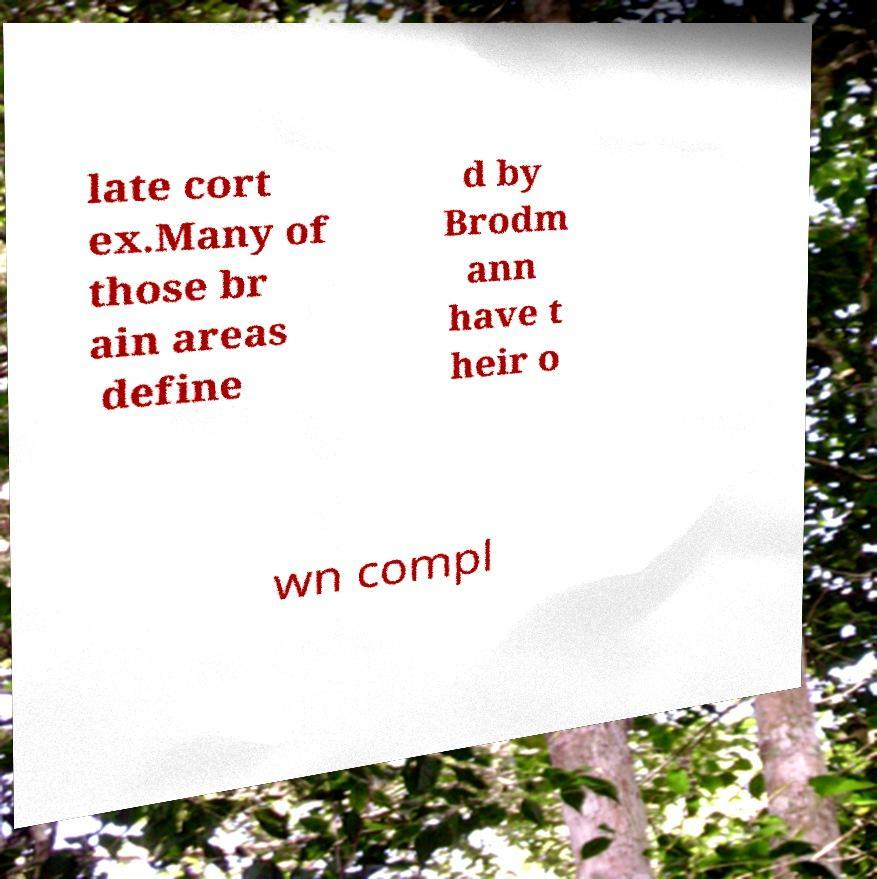Can you accurately transcribe the text from the provided image for me? late cort ex.Many of those br ain areas define d by Brodm ann have t heir o wn compl 